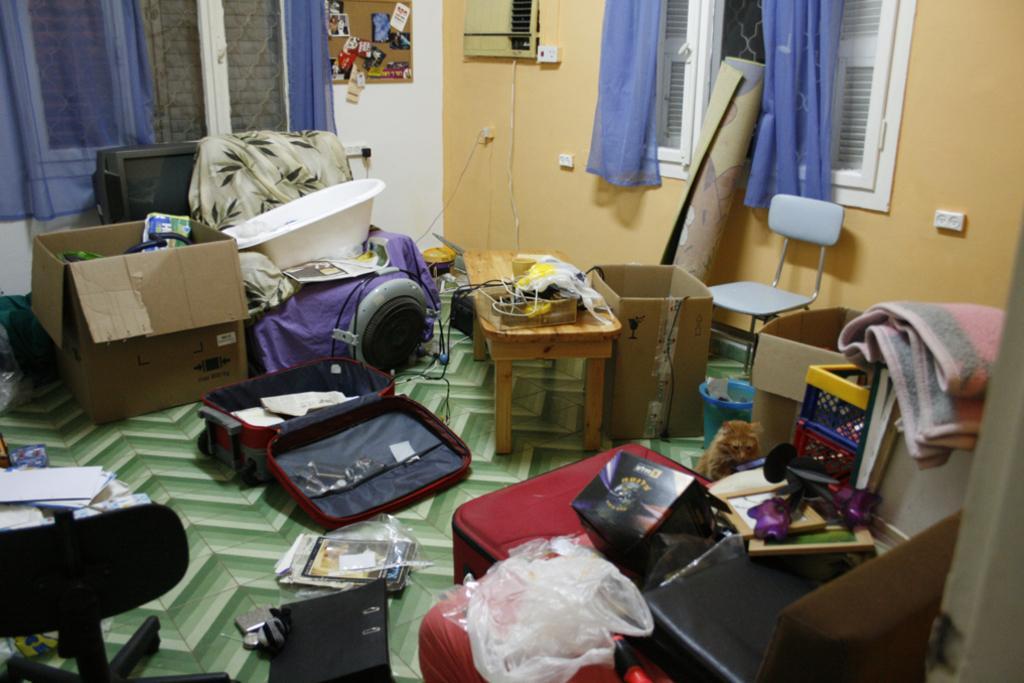Can you describe this image briefly? There are suitcases, chairs and other objects in the foreground area of the image, there are cardboard boxes, an equipment, windows, it seems like photographs, curtains, a mat and other objects in the background. 